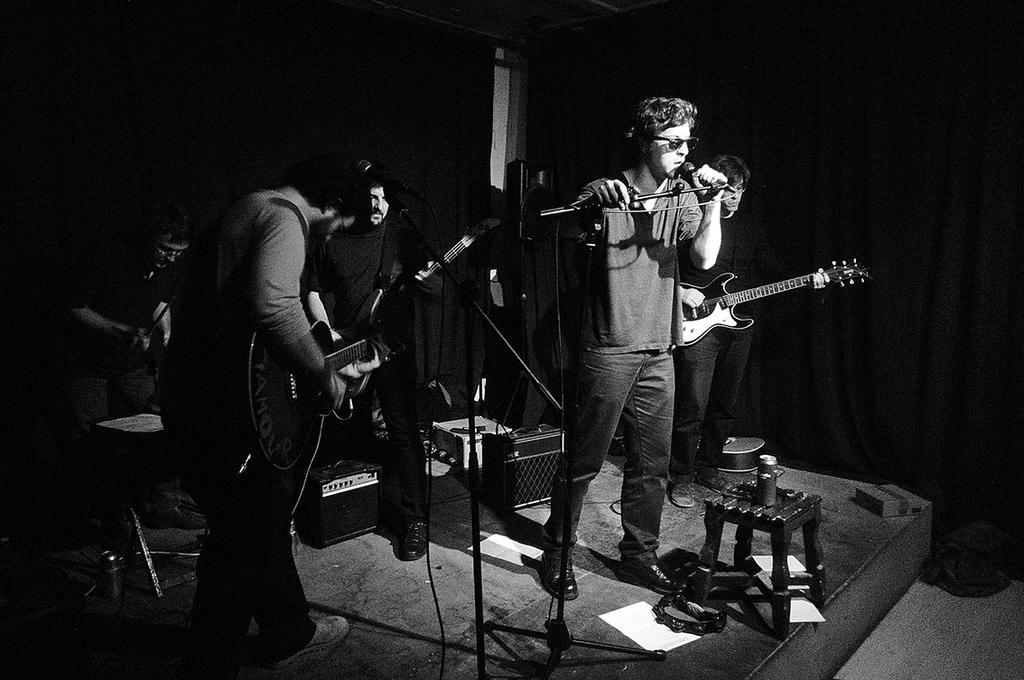Could you give a brief overview of what you see in this image? In this image there are few people in it. The man standing in the middle is holding a mic in his hand and singing while the man beside him is playing the guitar. The man to the left side is also playing the guitar with his hand. The man at the background is also holding the guitar. At the bottom there is a stool and a bottle on it. 